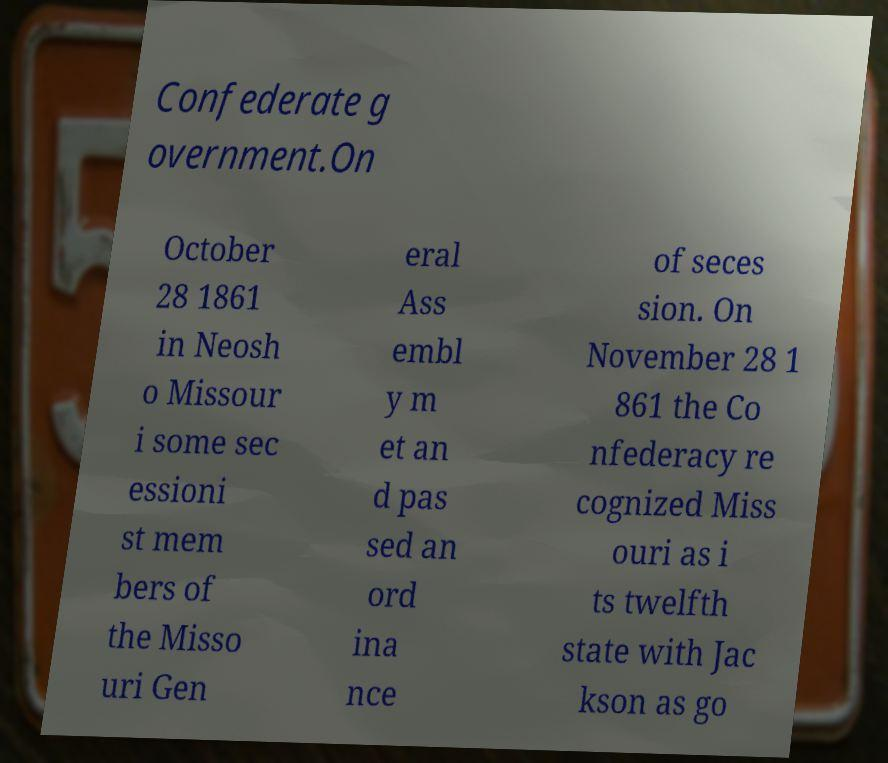Please read and relay the text visible in this image. What does it say? Confederate g overnment.On October 28 1861 in Neosh o Missour i some sec essioni st mem bers of the Misso uri Gen eral Ass embl y m et an d pas sed an ord ina nce of seces sion. On November 28 1 861 the Co nfederacy re cognized Miss ouri as i ts twelfth state with Jac kson as go 